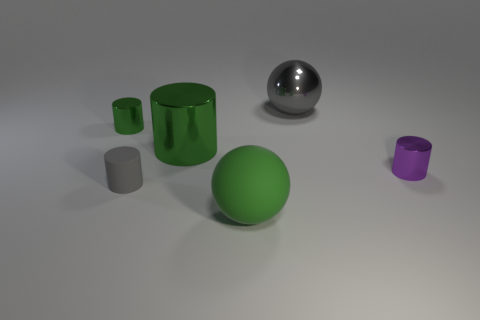Are there fewer gray shiny objects that are behind the big gray sphere than small red blocks?
Offer a very short reply. No. The ball that is in front of the big gray shiny object is what color?
Give a very brief answer. Green. There is a big sphere that is the same color as the small matte cylinder; what material is it?
Offer a terse response. Metal. Is there a tiny brown object of the same shape as the tiny purple object?
Your answer should be compact. No. How many purple shiny things have the same shape as the gray rubber object?
Your answer should be very brief. 1. Do the rubber cylinder and the big rubber thing have the same color?
Give a very brief answer. No. Are there fewer big gray metallic things than large red matte blocks?
Offer a terse response. No. What is the gray thing that is behind the purple shiny thing made of?
Make the answer very short. Metal. There is a green thing that is the same size as the matte sphere; what is its material?
Keep it short and to the point. Metal. There is a large ball that is left of the large gray ball that is to the right of the matte thing behind the large green rubber sphere; what is its material?
Offer a very short reply. Rubber. 